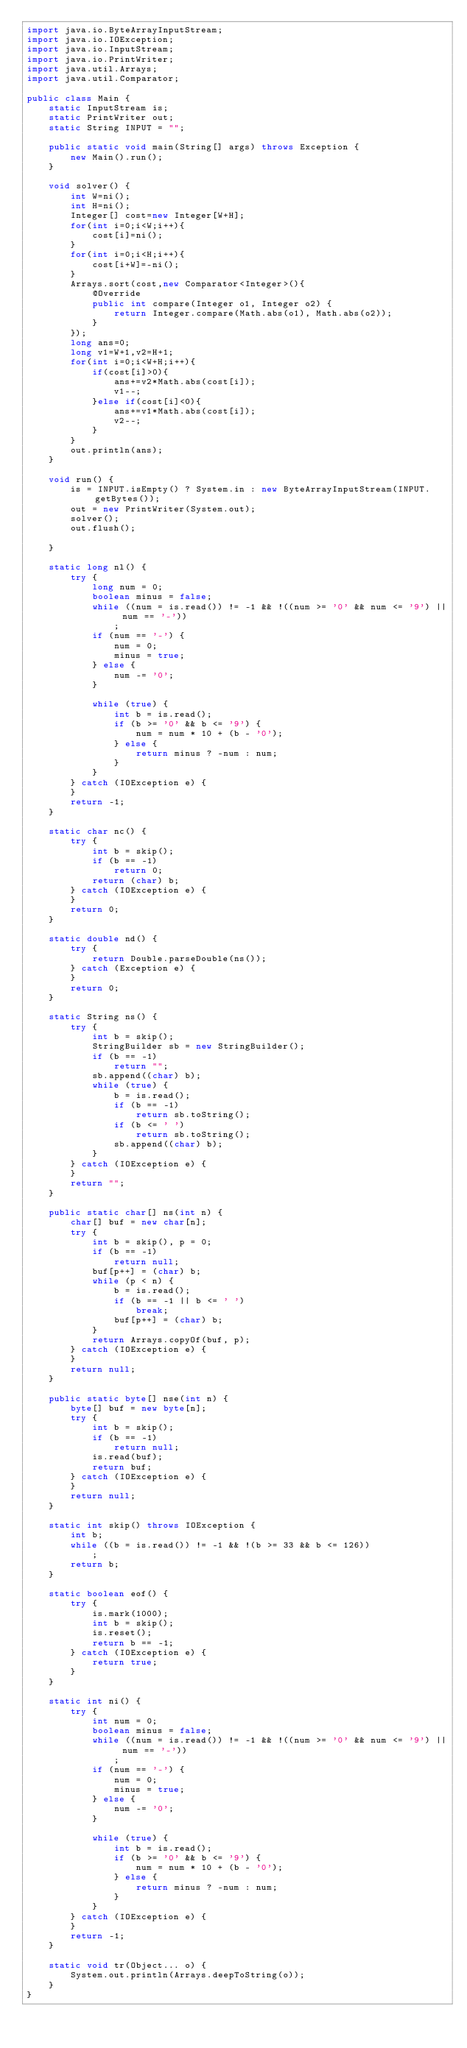<code> <loc_0><loc_0><loc_500><loc_500><_Java_>import java.io.ByteArrayInputStream;
import java.io.IOException;
import java.io.InputStream;
import java.io.PrintWriter;
import java.util.Arrays;
import java.util.Comparator;

public class Main {
	static InputStream is;
	static PrintWriter out;
	static String INPUT = "";

	public static void main(String[] args) throws Exception {
		new Main().run();
	}

	void solver() {
		int W=ni();
		int H=ni();
		Integer[] cost=new Integer[W+H];
		for(int i=0;i<W;i++){
			cost[i]=ni();
		}
		for(int i=0;i<H;i++){
			cost[i+W]=-ni();
		}
		Arrays.sort(cost,new Comparator<Integer>(){
			@Override
			public int compare(Integer o1, Integer o2) {
				return Integer.compare(Math.abs(o1), Math.abs(o2));
			}
		});
		long ans=0;
		long v1=W+1,v2=H+1;
		for(int i=0;i<W+H;i++){
			if(cost[i]>0){
				ans+=v2*Math.abs(cost[i]);
				v1--;
			}else if(cost[i]<0){
				ans+=v1*Math.abs(cost[i]);
				v2--;
			}
		}
		out.println(ans);
	}

	void run() {
		is = INPUT.isEmpty() ? System.in : new ByteArrayInputStream(INPUT.getBytes());
		out = new PrintWriter(System.out);
		solver();
		out.flush();

	}

	static long nl() {
		try {
			long num = 0;
			boolean minus = false;
			while ((num = is.read()) != -1 && !((num >= '0' && num <= '9') || num == '-'))
				;
			if (num == '-') {
				num = 0;
				minus = true;
			} else {
				num -= '0';
			}

			while (true) {
				int b = is.read();
				if (b >= '0' && b <= '9') {
					num = num * 10 + (b - '0');
				} else {
					return minus ? -num : num;
				}
			}
		} catch (IOException e) {
		}
		return -1;
	}

	static char nc() {
		try {
			int b = skip();
			if (b == -1)
				return 0;
			return (char) b;
		} catch (IOException e) {
		}
		return 0;
	}

	static double nd() {
		try {
			return Double.parseDouble(ns());
		} catch (Exception e) {
		}
		return 0;
	}

	static String ns() {
		try {
			int b = skip();
			StringBuilder sb = new StringBuilder();
			if (b == -1)
				return "";
			sb.append((char) b);
			while (true) {
				b = is.read();
				if (b == -1)
					return sb.toString();
				if (b <= ' ')
					return sb.toString();
				sb.append((char) b);
			}
		} catch (IOException e) {
		}
		return "";
	}

	public static char[] ns(int n) {
		char[] buf = new char[n];
		try {
			int b = skip(), p = 0;
			if (b == -1)
				return null;
			buf[p++] = (char) b;
			while (p < n) {
				b = is.read();
				if (b == -1 || b <= ' ')
					break;
				buf[p++] = (char) b;
			}
			return Arrays.copyOf(buf, p);
		} catch (IOException e) {
		}
		return null;
	}

	public static byte[] nse(int n) {
		byte[] buf = new byte[n];
		try {
			int b = skip();
			if (b == -1)
				return null;
			is.read(buf);
			return buf;
		} catch (IOException e) {
		}
		return null;
	}

	static int skip() throws IOException {
		int b;
		while ((b = is.read()) != -1 && !(b >= 33 && b <= 126))
			;
		return b;
	}

	static boolean eof() {
		try {
			is.mark(1000);
			int b = skip();
			is.reset();
			return b == -1;
		} catch (IOException e) {
			return true;
		}
	}

	static int ni() {
		try {
			int num = 0;
			boolean minus = false;
			while ((num = is.read()) != -1 && !((num >= '0' && num <= '9') || num == '-'))
				;
			if (num == '-') {
				num = 0;
				minus = true;
			} else {
				num -= '0';
			}

			while (true) {
				int b = is.read();
				if (b >= '0' && b <= '9') {
					num = num * 10 + (b - '0');
				} else {
					return minus ? -num : num;
				}
			}
		} catch (IOException e) {
		}
		return -1;
	}

	static void tr(Object... o) {
		System.out.println(Arrays.deepToString(o));
	}
}

</code> 